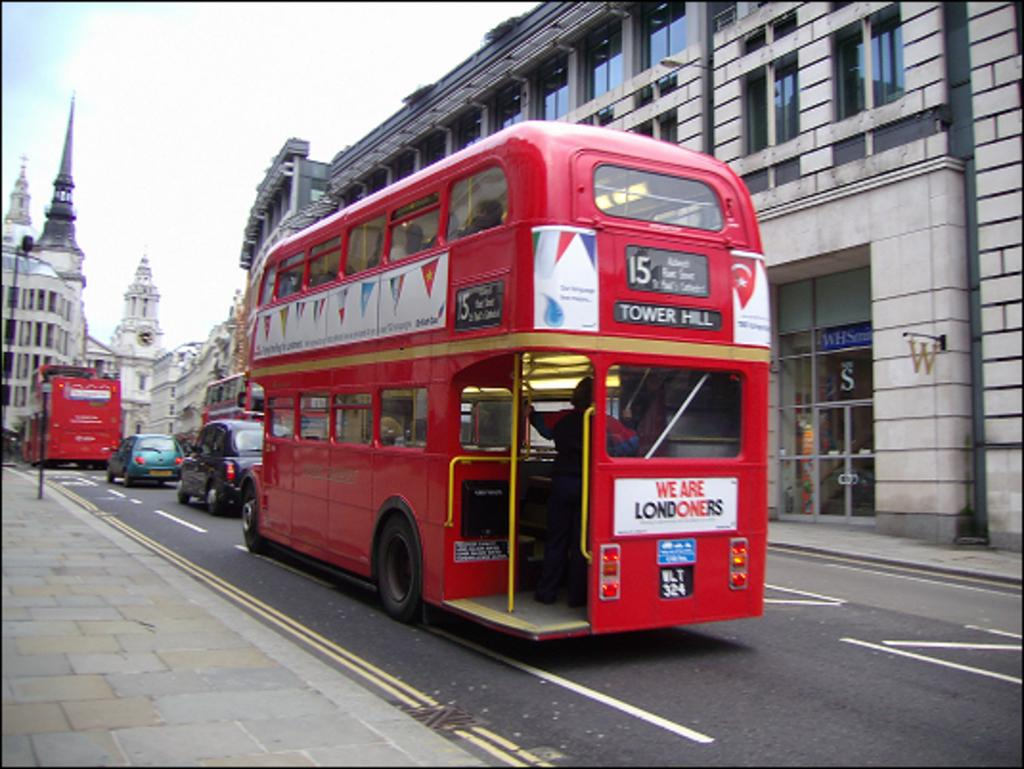<image>
Provide a brief description of the given image. A red double decker bus with Tower Hill on the front. 